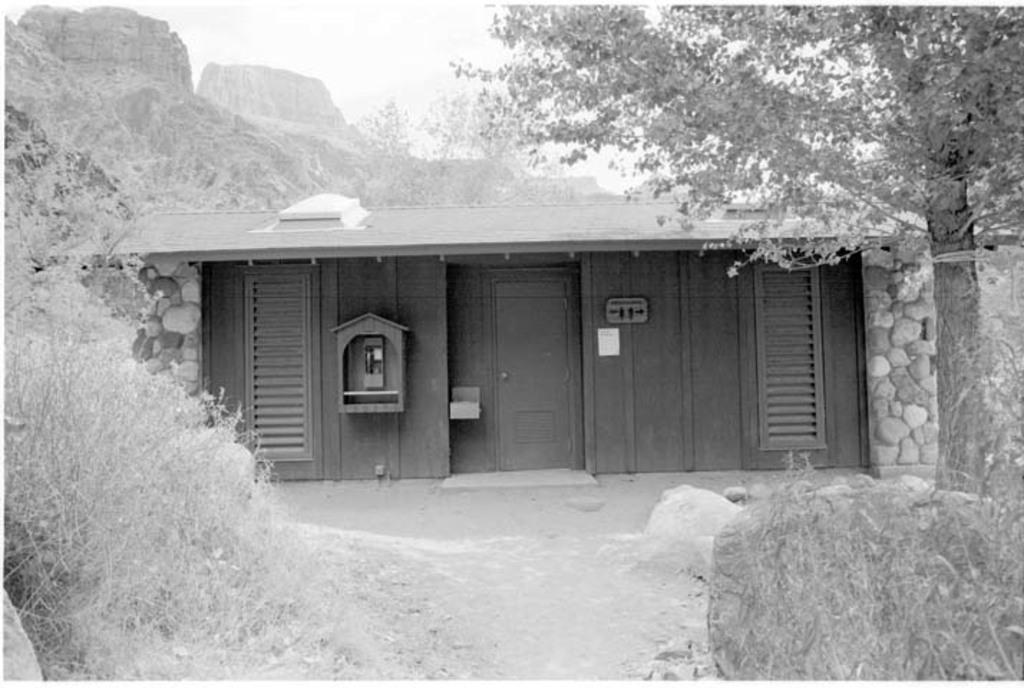In one or two sentences, can you explain what this image depicts? This is a black and white picture where we can see plants, rocks, wooden house, trees, rock hills and the sky in the background. 